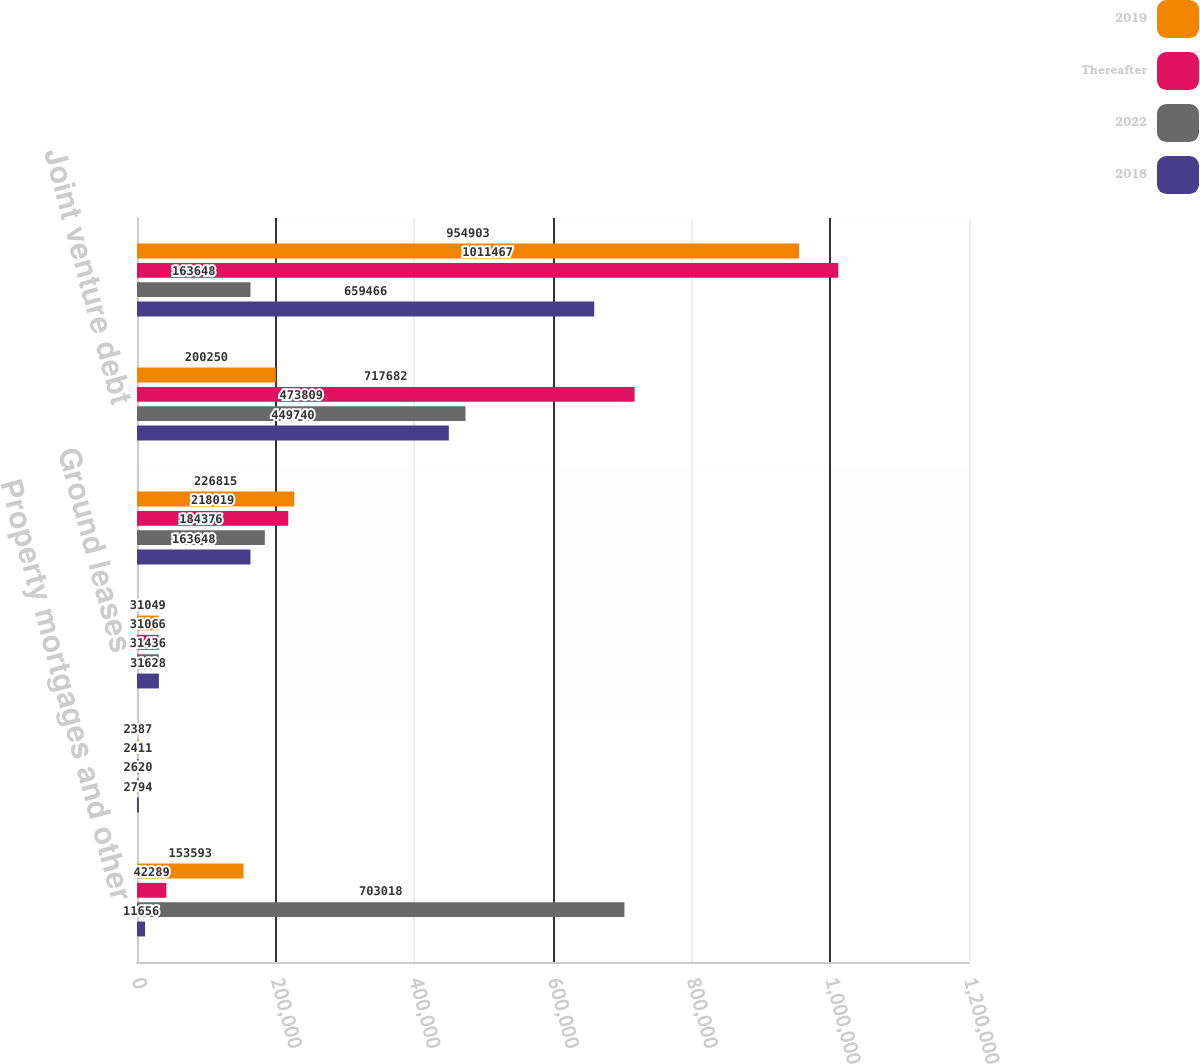Convert chart to OTSL. <chart><loc_0><loc_0><loc_500><loc_500><stacked_bar_chart><ecel><fcel>Property mortgages and other<fcel>Capital lease<fcel>Ground leases<fcel>Estimated interest expense<fcel>Joint venture debt<fcel>Total<nl><fcel>2019<fcel>153593<fcel>2387<fcel>31049<fcel>226815<fcel>200250<fcel>954903<nl><fcel>Thereafter<fcel>42289<fcel>2411<fcel>31066<fcel>218019<fcel>717682<fcel>1.01147e+06<nl><fcel>2022<fcel>703018<fcel>2620<fcel>31436<fcel>184376<fcel>473809<fcel>163648<nl><fcel>2018<fcel>11656<fcel>2794<fcel>31628<fcel>163648<fcel>449740<fcel>659466<nl></chart> 